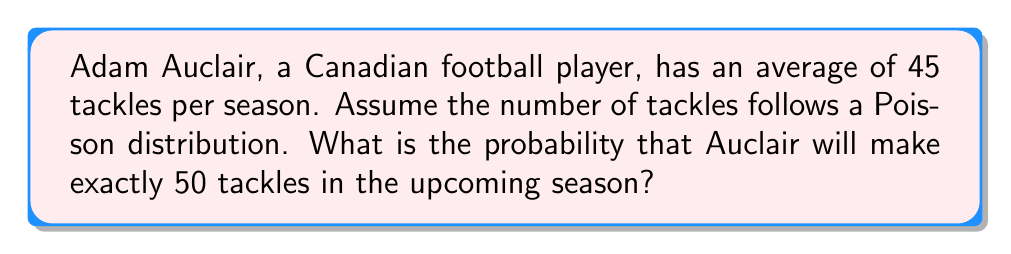Could you help me with this problem? Let's approach this step-by-step:

1) The Poisson distribution is used for discrete events occurring in a fixed interval of time or space, where the average rate is known. It's suitable for modeling the number of tackles in a season.

2) The Poisson probability mass function is:

   $$P(X = k) = \frac{e^{-\lambda} \lambda^k}{k!}$$

   Where:
   - $\lambda$ is the average rate of occurrence
   - $k$ is the number of occurrences we're interested in
   - $e$ is Euler's number (approximately 2.71828)

3) In this case:
   - $\lambda = 45$ (average tackles per season)
   - $k = 50$ (we're looking for exactly 50 tackles)

4) Let's substitute these values into the formula:

   $$P(X = 50) = \frac{e^{-45} 45^{50}}{50!}$$

5) This can be calculated using a scientific calculator or computer. The result is approximately 0.0358.

6) To interpret this: there's about a 3.58% chance that Auclair will make exactly 50 tackles in the upcoming season.
Answer: $0.0358$ or $3.58\%$ 